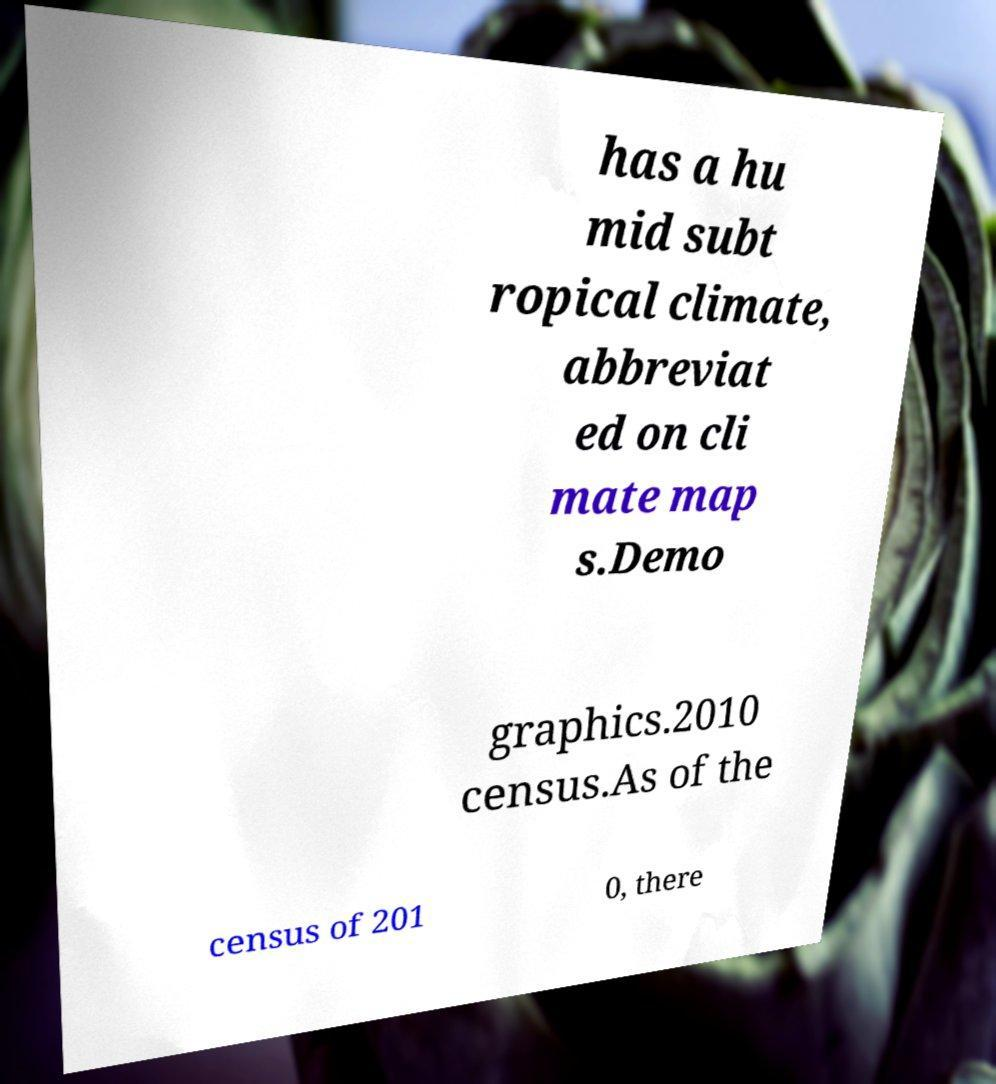Can you read and provide the text displayed in the image?This photo seems to have some interesting text. Can you extract and type it out for me? has a hu mid subt ropical climate, abbreviat ed on cli mate map s.Demo graphics.2010 census.As of the census of 201 0, there 